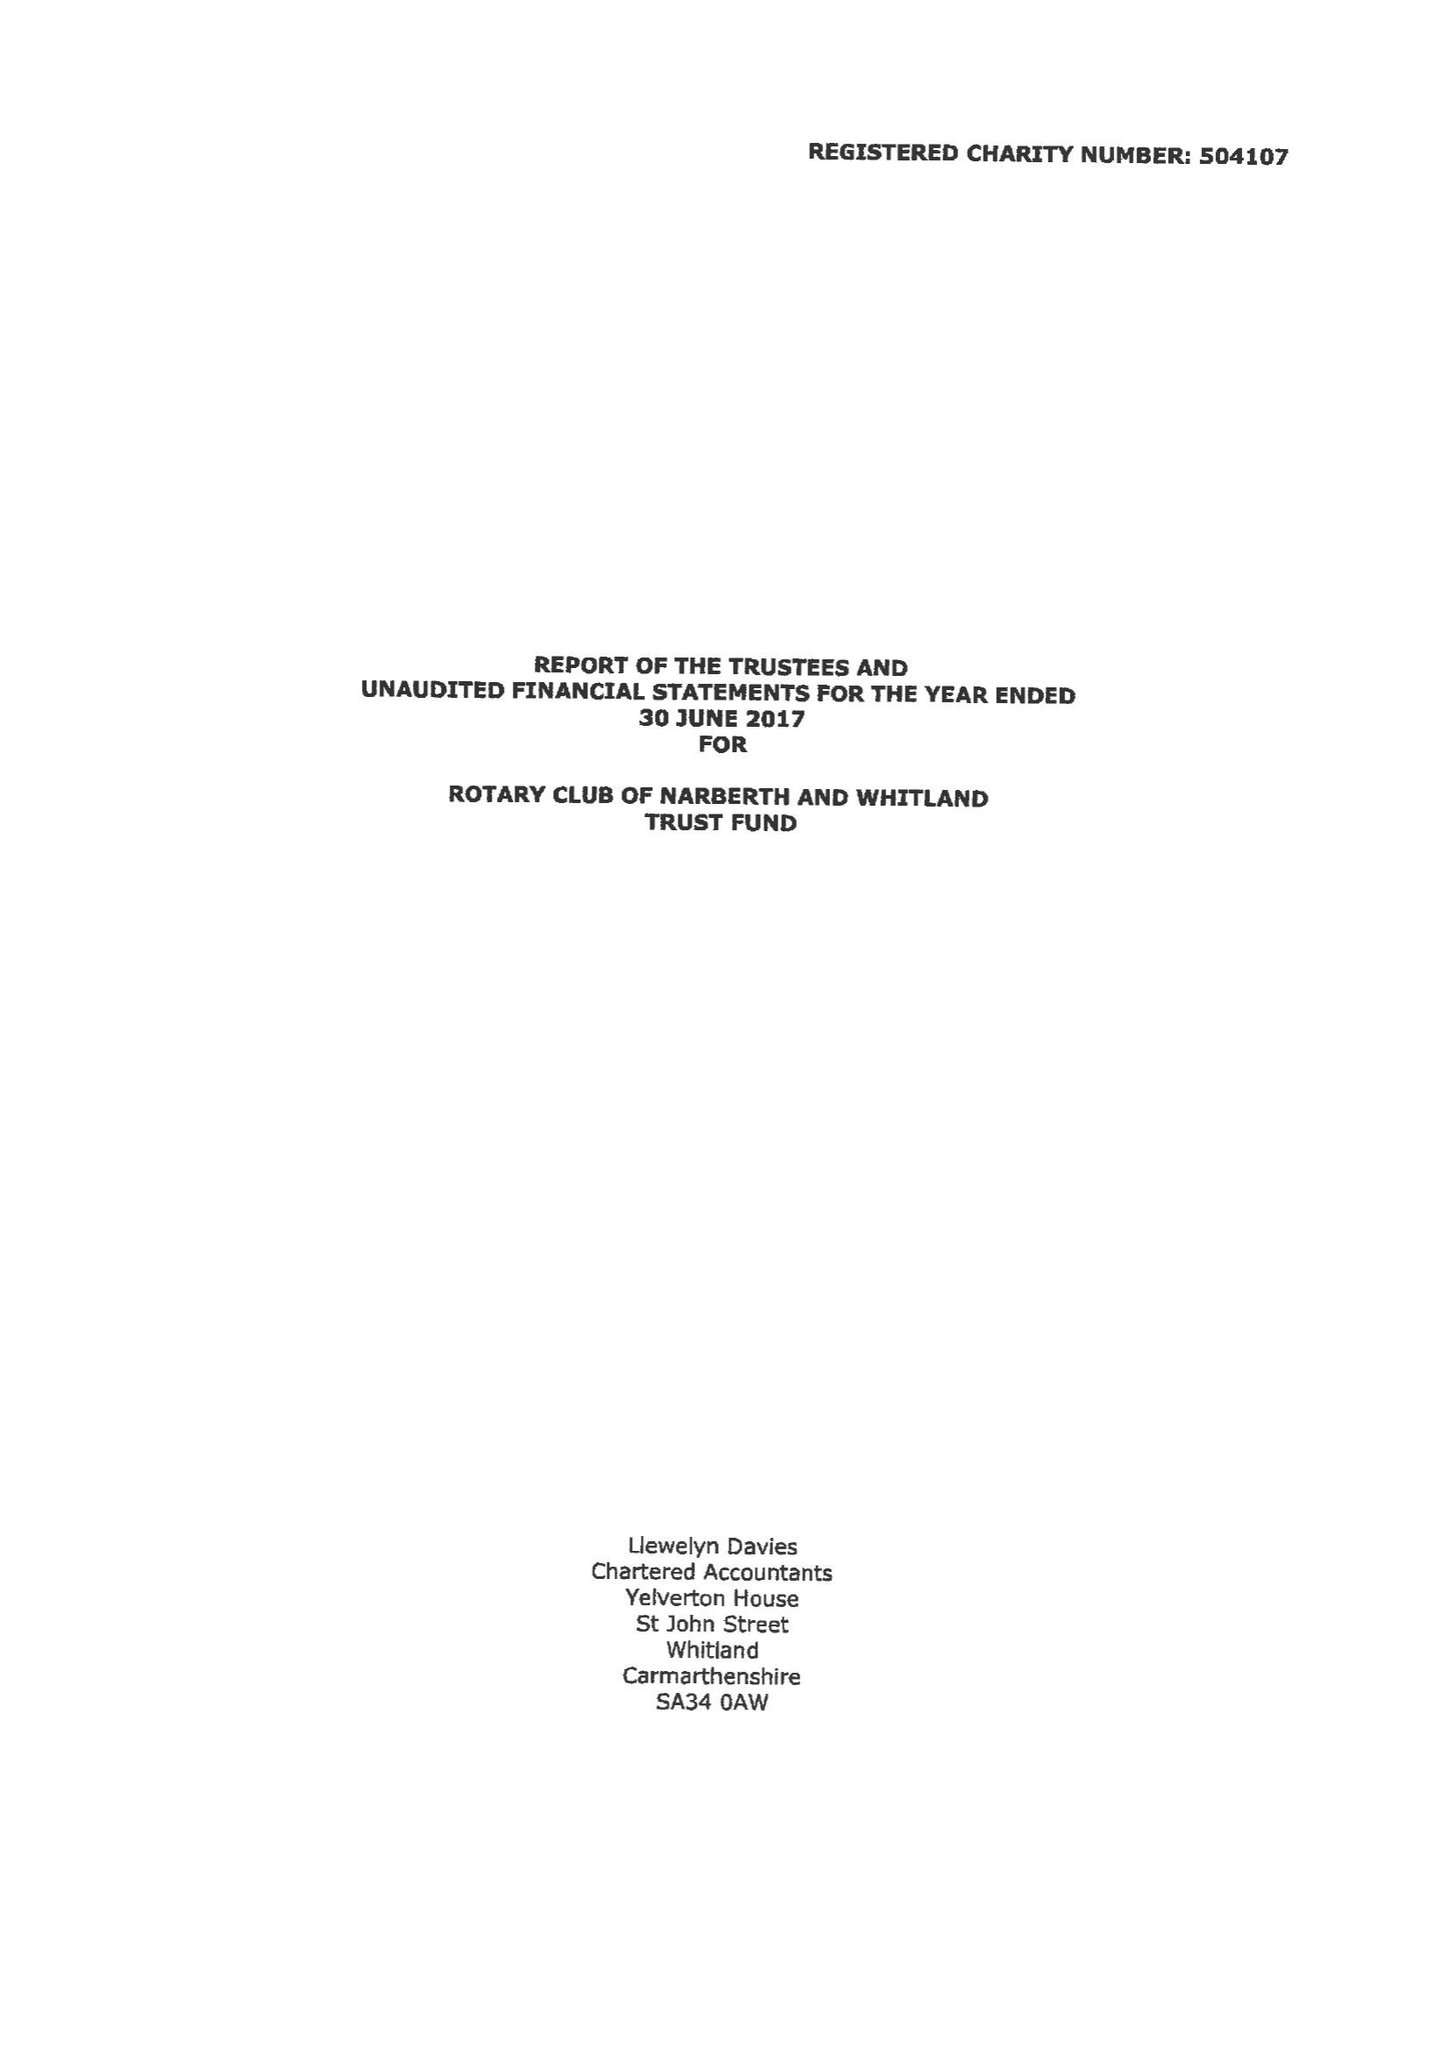What is the value for the address__postcode?
Answer the question using a single word or phrase. SA67 8RP 